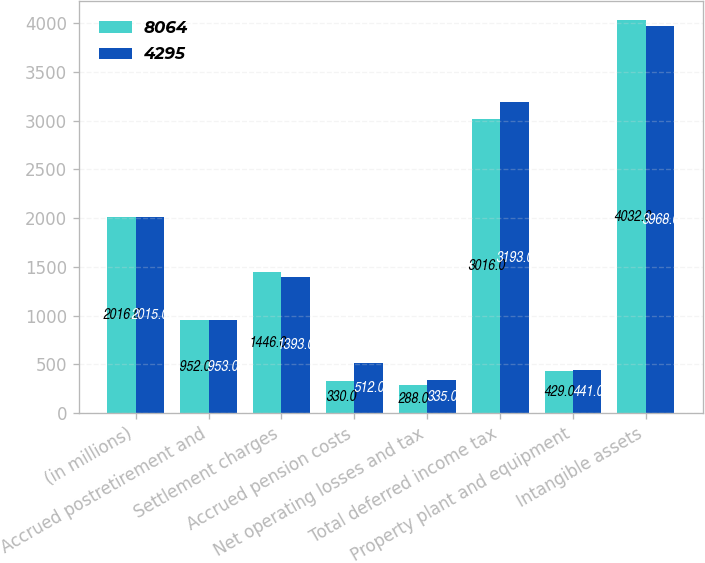Convert chart to OTSL. <chart><loc_0><loc_0><loc_500><loc_500><stacked_bar_chart><ecel><fcel>(in millions)<fcel>Accrued postretirement and<fcel>Settlement charges<fcel>Accrued pension costs<fcel>Net operating losses and tax<fcel>Total deferred income tax<fcel>Property plant and equipment<fcel>Intangible assets<nl><fcel>8064<fcel>2016<fcel>952<fcel>1446<fcel>330<fcel>288<fcel>3016<fcel>429<fcel>4032<nl><fcel>4295<fcel>2015<fcel>953<fcel>1393<fcel>512<fcel>335<fcel>3193<fcel>441<fcel>3968<nl></chart> 